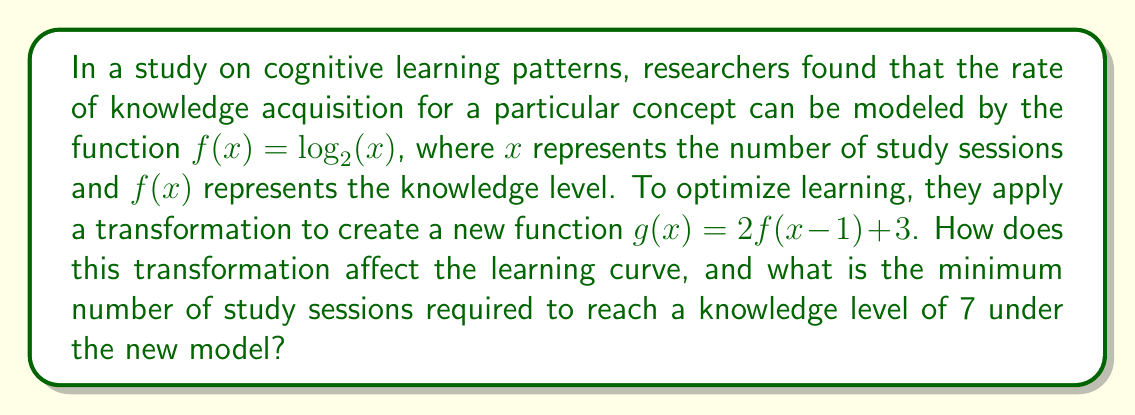Give your solution to this math problem. To understand how the transformation affects the learning curve and to find the minimum number of study sessions required, let's break down the problem step-by-step:

1. Original function: $f(x) = \log_2(x)$

2. Transformed function: $g(x) = 2f(x-1) + 3$

3. Let's analyze the transformation:
   a. $f(x-1)$: This shifts the function 1 unit to the right, delaying the start of learning.
   b. $2f(x-1)$: This vertically stretches the function by a factor of 2, steepening the learning curve.
   c. $2f(x-1) + 3$: This shifts the function 3 units up, increasing the initial knowledge level.

4. To find the minimum number of study sessions, we need to solve the equation:
   $g(x) = 7$

5. Substituting the transformed function:
   $2f(x-1) + 3 = 7$

6. Simplifying:
   $2f(x-1) = 4$
   $f(x-1) = 2$

7. Substituting the original function:
   $\log_2(x-1) = 2$

8. Solving for x:
   $x - 1 = 2^2 = 4$
   $x = 5$

Therefore, the minimum number of study sessions required to reach a knowledge level of 7 under the new model is 5.

The transformation affects the learning curve in the following ways:
1. It delays the start of learning by one session.
2. It steepens the learning curve, indicating faster knowledge acquisition.
3. It raises the initial knowledge level, suggesting some prior understanding or a more effective learning method.
Answer: The transformation steepens the learning curve, delays the start of learning by one session, and raises the initial knowledge level. The minimum number of study sessions required to reach a knowledge level of 7 under the new model is 5. 